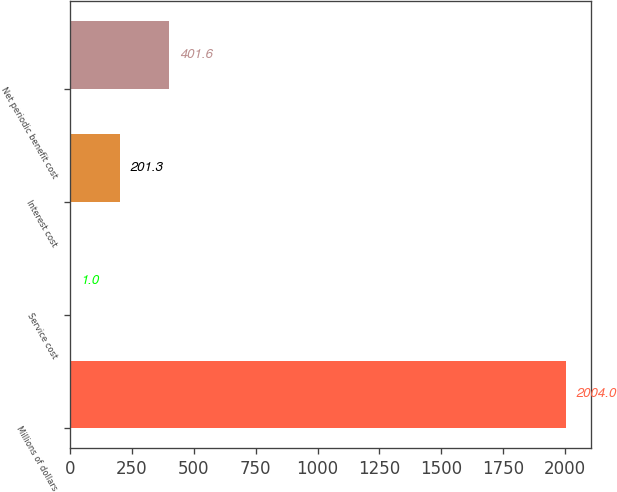Convert chart. <chart><loc_0><loc_0><loc_500><loc_500><bar_chart><fcel>Millions of dollars<fcel>Service cost<fcel>Interest cost<fcel>Net periodic benefit cost<nl><fcel>2004<fcel>1<fcel>201.3<fcel>401.6<nl></chart> 